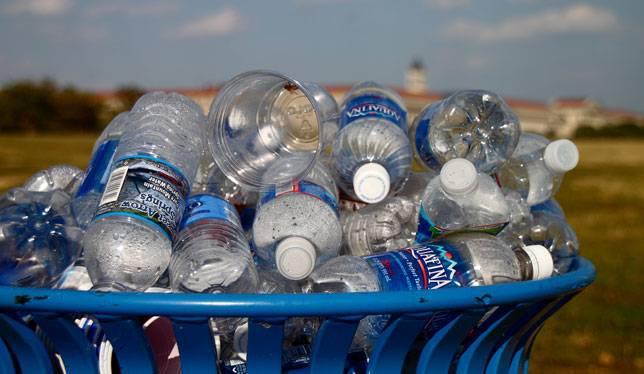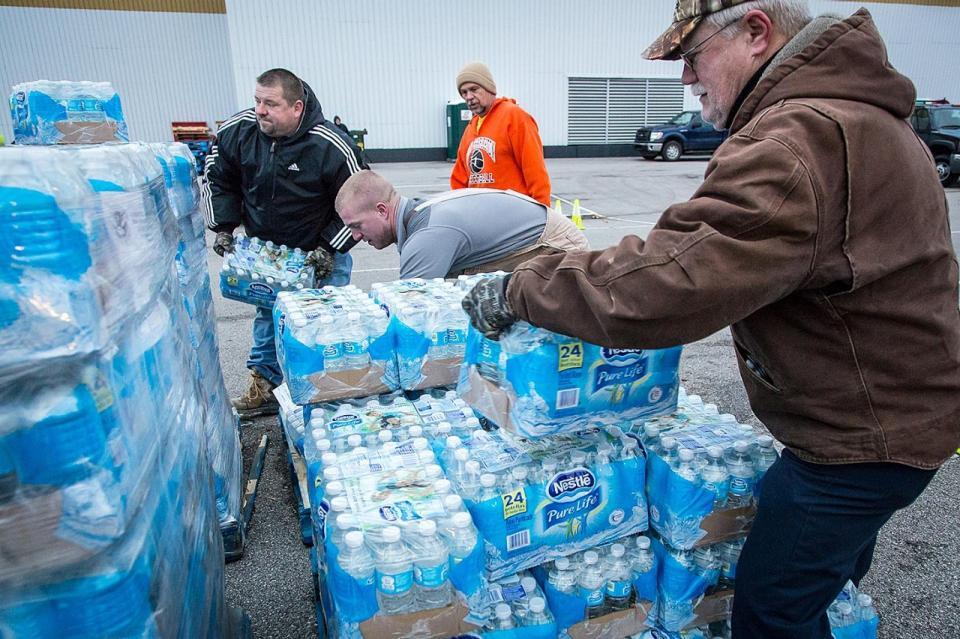The first image is the image on the left, the second image is the image on the right. For the images shown, is this caption "There are at least two people in the image on the right." true? Answer yes or no. Yes. 